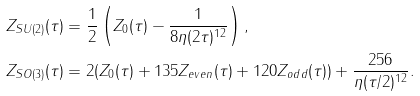<formula> <loc_0><loc_0><loc_500><loc_500>Z _ { S U ( 2 ) } ( \tau ) & = \frac { 1 } { 2 } \left ( { Z } _ { 0 } ( \tau ) - \frac { 1 } { 8 \eta ( 2 \tau ) ^ { 1 2 } } \right ) , \\ Z _ { S O ( 3 ) } ( \tau ) & = 2 ( { Z } _ { 0 } ( \tau ) + 1 3 5 { Z } _ { e v e n } ( \tau ) + 1 2 0 { Z } _ { o d d } ( \tau ) ) + \frac { 2 5 6 } { \eta ( \tau / 2 ) ^ { 1 2 } } .</formula> 